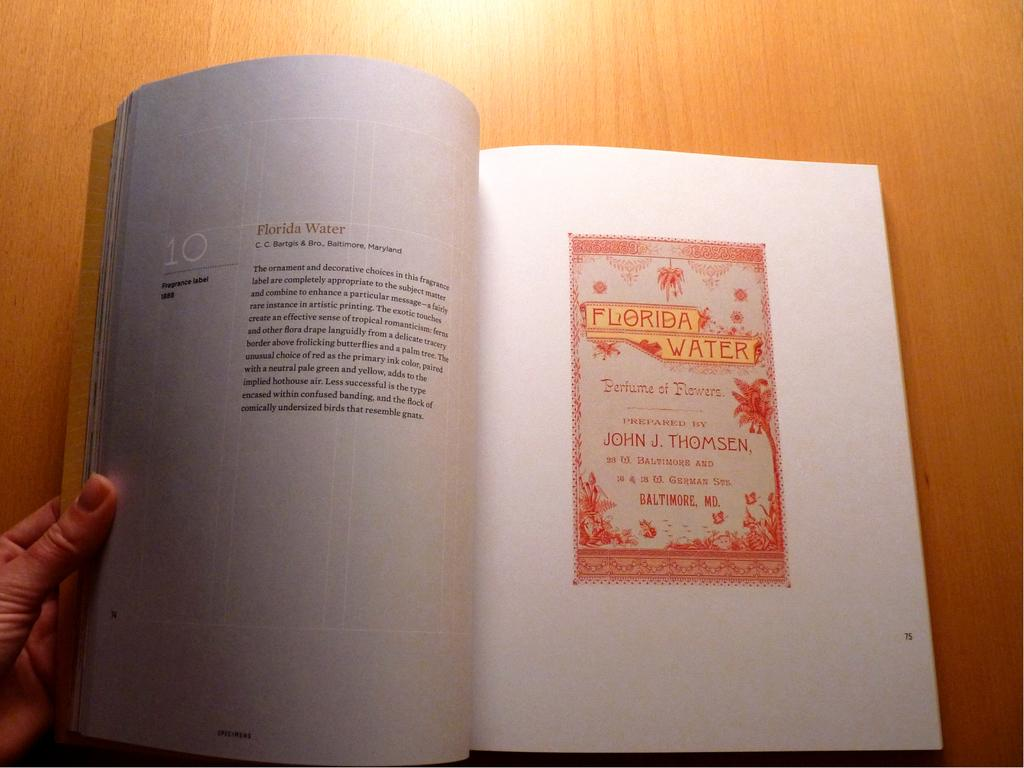<image>
Offer a succinct explanation of the picture presented. A book is open to the page on Florida Water. 